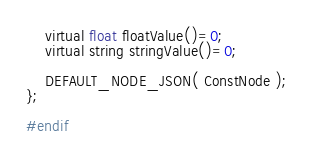<code> <loc_0><loc_0><loc_500><loc_500><_C_>	virtual float floatValue()=0;
	virtual string stringValue()=0;

	DEFAULT_NODE_JSON( ConstNode );
};

#endif
</code> 